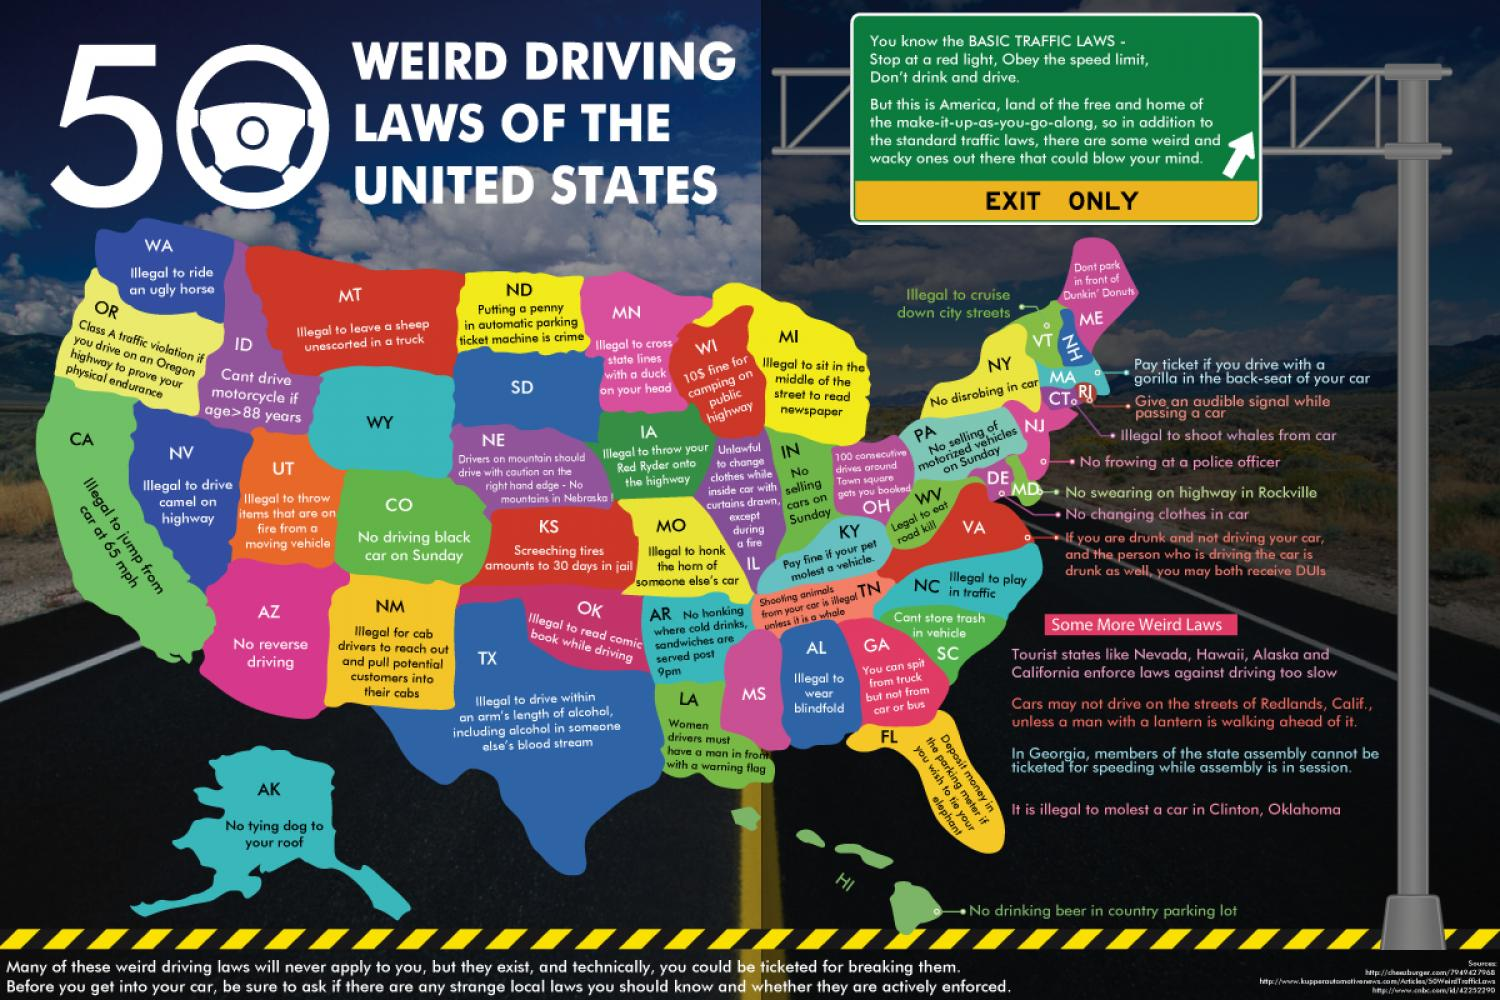Specify some key components in this picture. It is unlawful in the state of Iowa to dispose of a red Ryder bicycle on a highway. In Maryland, it is illegal to use a kerosene heater on a highway in Rockville. 